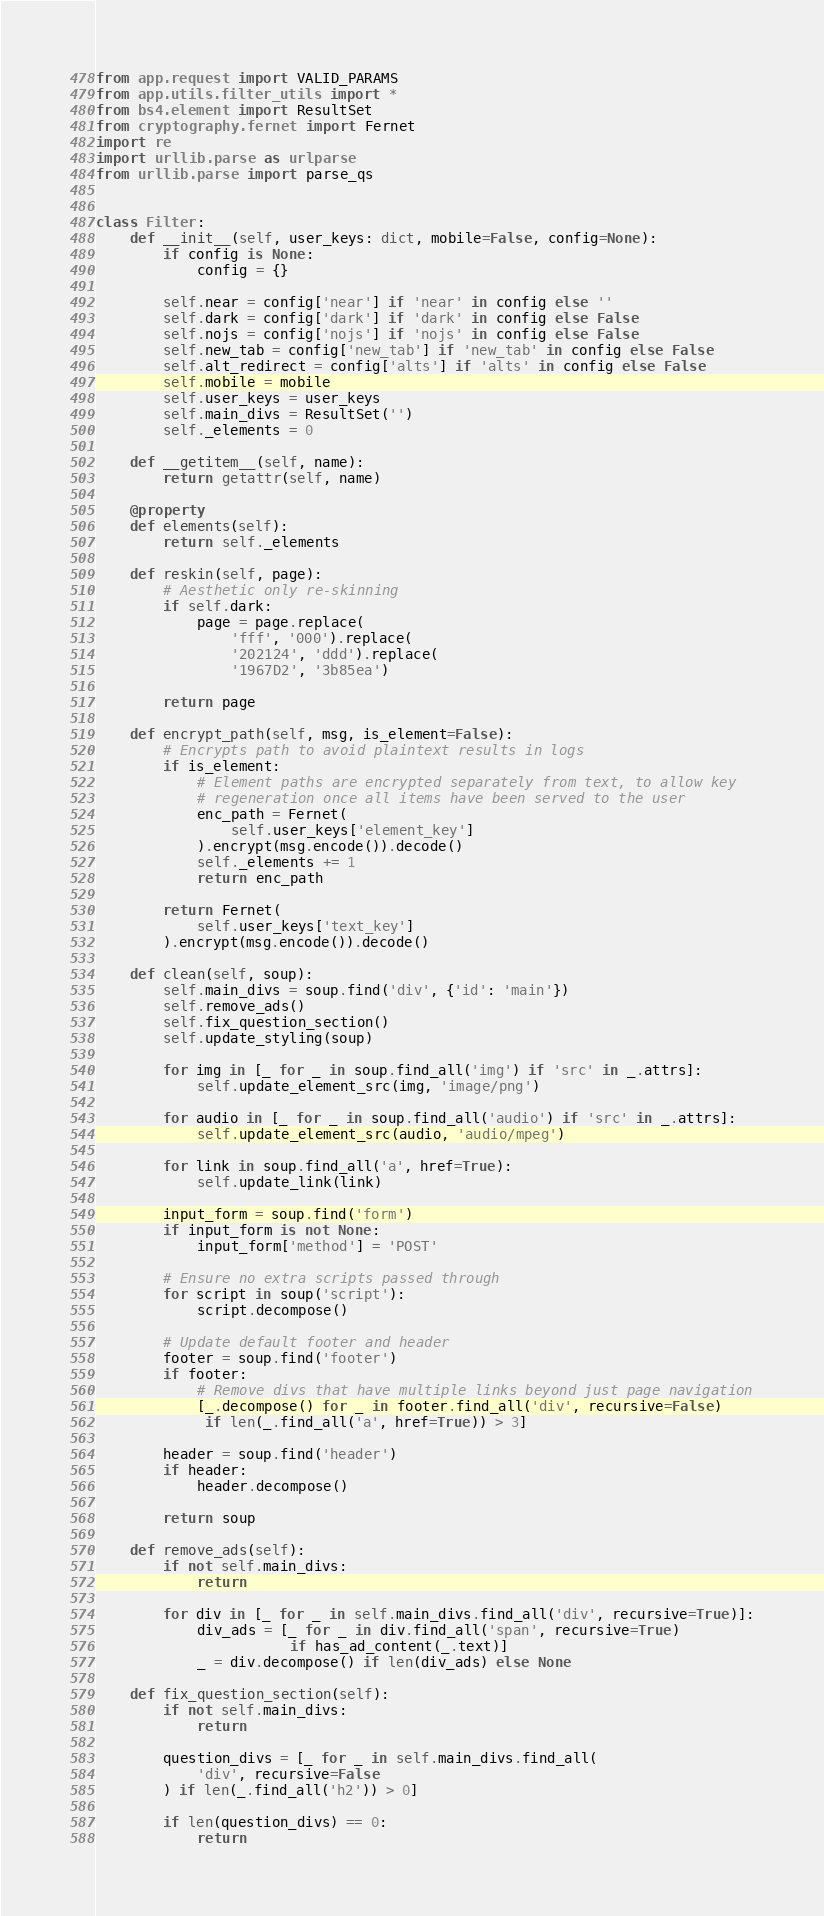Convert code to text. <code><loc_0><loc_0><loc_500><loc_500><_Python_>from app.request import VALID_PARAMS
from app.utils.filter_utils import *
from bs4.element import ResultSet
from cryptography.fernet import Fernet
import re
import urllib.parse as urlparse
from urllib.parse import parse_qs


class Filter:
    def __init__(self, user_keys: dict, mobile=False, config=None):
        if config is None:
            config = {}

        self.near = config['near'] if 'near' in config else ''
        self.dark = config['dark'] if 'dark' in config else False
        self.nojs = config['nojs'] if 'nojs' in config else False
        self.new_tab = config['new_tab'] if 'new_tab' in config else False
        self.alt_redirect = config['alts'] if 'alts' in config else False
        self.mobile = mobile
        self.user_keys = user_keys
        self.main_divs = ResultSet('')
        self._elements = 0

    def __getitem__(self, name):
        return getattr(self, name)

    @property
    def elements(self):
        return self._elements

    def reskin(self, page):
        # Aesthetic only re-skinning
        if self.dark:
            page = page.replace(
                'fff', '000').replace(
                '202124', 'ddd').replace(
                '1967D2', '3b85ea')

        return page

    def encrypt_path(self, msg, is_element=False):
        # Encrypts path to avoid plaintext results in logs
        if is_element:
            # Element paths are encrypted separately from text, to allow key
            # regeneration once all items have been served to the user
            enc_path = Fernet(
                self.user_keys['element_key']
            ).encrypt(msg.encode()).decode()
            self._elements += 1
            return enc_path

        return Fernet(
            self.user_keys['text_key']
        ).encrypt(msg.encode()).decode()

    def clean(self, soup):
        self.main_divs = soup.find('div', {'id': 'main'})
        self.remove_ads()
        self.fix_question_section()
        self.update_styling(soup)

        for img in [_ for _ in soup.find_all('img') if 'src' in _.attrs]:
            self.update_element_src(img, 'image/png')

        for audio in [_ for _ in soup.find_all('audio') if 'src' in _.attrs]:
            self.update_element_src(audio, 'audio/mpeg')

        for link in soup.find_all('a', href=True):
            self.update_link(link)

        input_form = soup.find('form')
        if input_form is not None:
            input_form['method'] = 'POST'

        # Ensure no extra scripts passed through
        for script in soup('script'):
            script.decompose()

        # Update default footer and header
        footer = soup.find('footer')
        if footer:
            # Remove divs that have multiple links beyond just page navigation
            [_.decompose() for _ in footer.find_all('div', recursive=False)
             if len(_.find_all('a', href=True)) > 3]

        header = soup.find('header')
        if header:
            header.decompose()

        return soup

    def remove_ads(self):
        if not self.main_divs:
            return

        for div in [_ for _ in self.main_divs.find_all('div', recursive=True)]:
            div_ads = [_ for _ in div.find_all('span', recursive=True)
                       if has_ad_content(_.text)]
            _ = div.decompose() if len(div_ads) else None

    def fix_question_section(self):
        if not self.main_divs:
            return

        question_divs = [_ for _ in self.main_divs.find_all(
            'div', recursive=False
        ) if len(_.find_all('h2')) > 0]

        if len(question_divs) == 0:
            return
</code> 